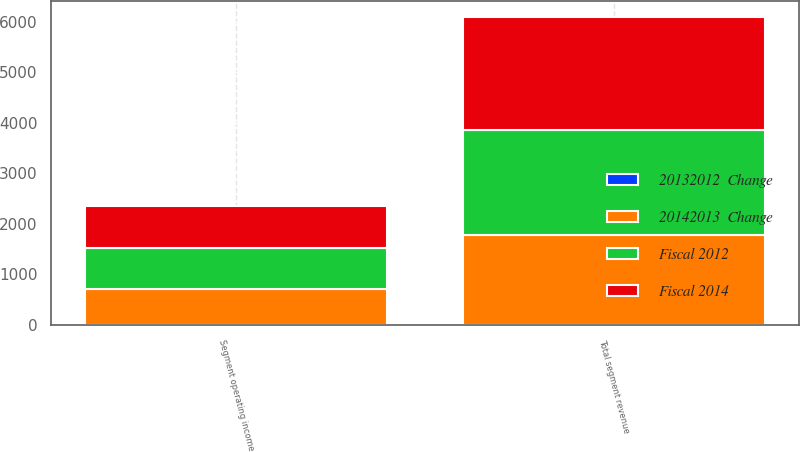Convert chart. <chart><loc_0><loc_0><loc_500><loc_500><stacked_bar_chart><ecel><fcel>Total segment revenue<fcel>Segment operating income<nl><fcel>Fiscal 2014<fcel>2253<fcel>843<nl><fcel>Fiscal 2012<fcel>2057<fcel>800<nl><fcel>20142013  Change<fcel>1779<fcel>712<nl><fcel>20132012  Change<fcel>10<fcel>5<nl></chart> 